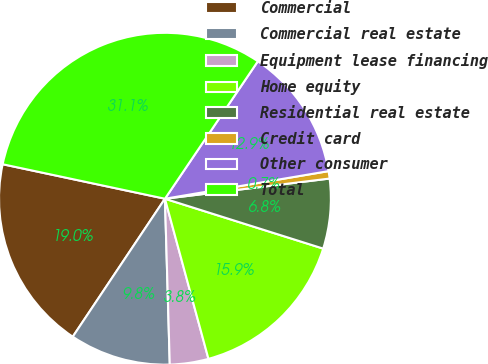<chart> <loc_0><loc_0><loc_500><loc_500><pie_chart><fcel>Commercial<fcel>Commercial real estate<fcel>Equipment lease financing<fcel>Home equity<fcel>Residential real estate<fcel>Credit card<fcel>Other consumer<fcel>Total<nl><fcel>18.96%<fcel>9.84%<fcel>3.76%<fcel>15.92%<fcel>6.8%<fcel>0.72%<fcel>12.88%<fcel>31.13%<nl></chart> 